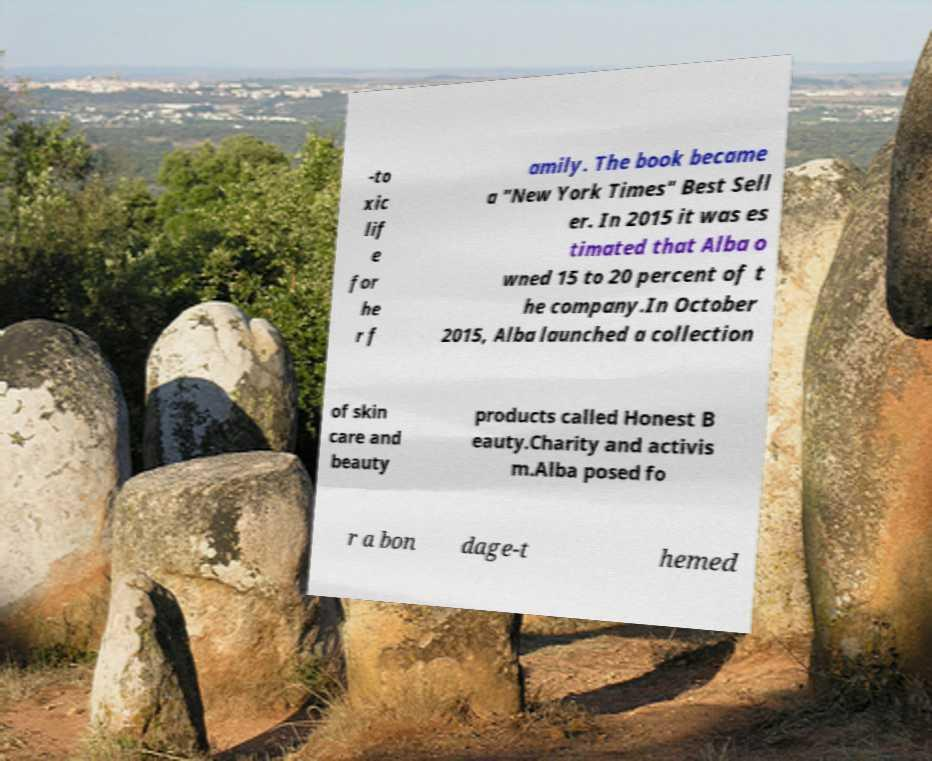I need the written content from this picture converted into text. Can you do that? -to xic lif e for he r f amily. The book became a "New York Times" Best Sell er. In 2015 it was es timated that Alba o wned 15 to 20 percent of t he company.In October 2015, Alba launched a collection of skin care and beauty products called Honest B eauty.Charity and activis m.Alba posed fo r a bon dage-t hemed 